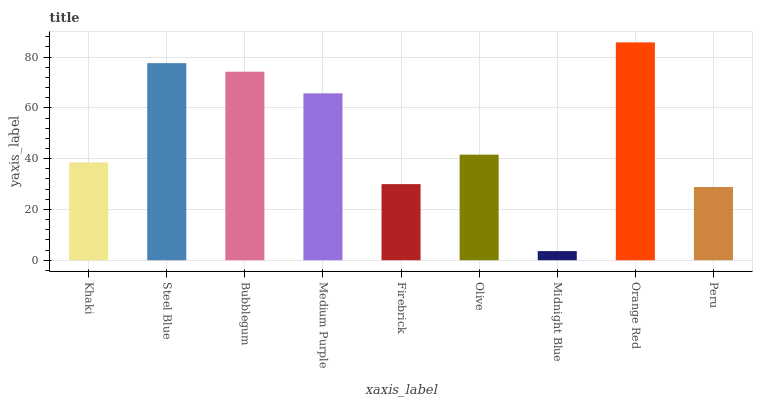Is Midnight Blue the minimum?
Answer yes or no. Yes. Is Orange Red the maximum?
Answer yes or no. Yes. Is Steel Blue the minimum?
Answer yes or no. No. Is Steel Blue the maximum?
Answer yes or no. No. Is Steel Blue greater than Khaki?
Answer yes or no. Yes. Is Khaki less than Steel Blue?
Answer yes or no. Yes. Is Khaki greater than Steel Blue?
Answer yes or no. No. Is Steel Blue less than Khaki?
Answer yes or no. No. Is Olive the high median?
Answer yes or no. Yes. Is Olive the low median?
Answer yes or no. Yes. Is Bubblegum the high median?
Answer yes or no. No. Is Medium Purple the low median?
Answer yes or no. No. 